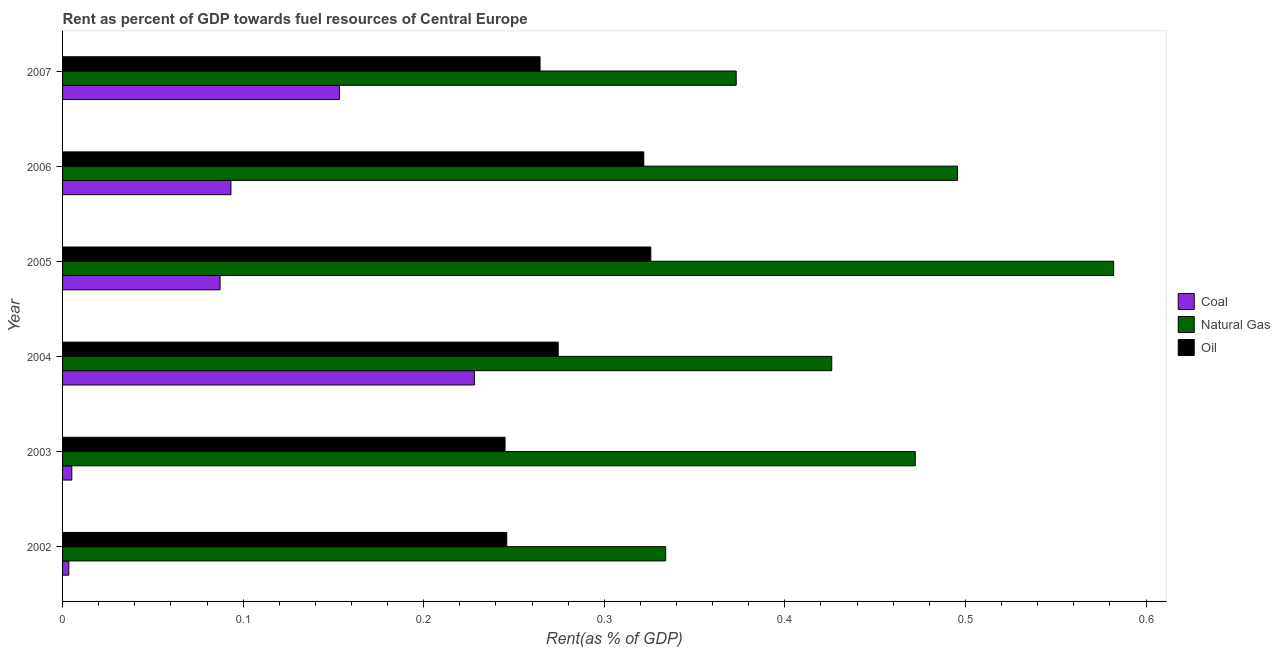How many different coloured bars are there?
Make the answer very short. 3. How many groups of bars are there?
Your answer should be compact. 6. How many bars are there on the 5th tick from the top?
Give a very brief answer. 3. How many bars are there on the 4th tick from the bottom?
Your response must be concise. 3. What is the rent towards natural gas in 2006?
Your answer should be compact. 0.5. Across all years, what is the maximum rent towards natural gas?
Your response must be concise. 0.58. Across all years, what is the minimum rent towards natural gas?
Keep it short and to the point. 0.33. In which year was the rent towards coal maximum?
Your answer should be very brief. 2004. What is the total rent towards natural gas in the graph?
Provide a short and direct response. 2.68. What is the difference between the rent towards coal in 2003 and that in 2007?
Provide a succinct answer. -0.15. What is the difference between the rent towards natural gas in 2006 and the rent towards coal in 2005?
Your answer should be very brief. 0.41. What is the average rent towards natural gas per year?
Keep it short and to the point. 0.45. In the year 2007, what is the difference between the rent towards natural gas and rent towards oil?
Offer a terse response. 0.11. In how many years, is the rent towards oil greater than 0.4 %?
Your answer should be very brief. 0. What is the ratio of the rent towards oil in 2002 to that in 2005?
Your response must be concise. 0.76. Is the rent towards coal in 2002 less than that in 2003?
Make the answer very short. Yes. Is the difference between the rent towards oil in 2006 and 2007 greater than the difference between the rent towards coal in 2006 and 2007?
Your answer should be very brief. Yes. What is the difference between the highest and the second highest rent towards coal?
Provide a succinct answer. 0.07. What is the difference between the highest and the lowest rent towards oil?
Your answer should be compact. 0.08. In how many years, is the rent towards coal greater than the average rent towards coal taken over all years?
Provide a short and direct response. 2. What does the 2nd bar from the top in 2006 represents?
Provide a short and direct response. Natural Gas. What does the 1st bar from the bottom in 2002 represents?
Keep it short and to the point. Coal. Is it the case that in every year, the sum of the rent towards coal and rent towards natural gas is greater than the rent towards oil?
Provide a succinct answer. Yes. How many bars are there?
Your answer should be very brief. 18. Are all the bars in the graph horizontal?
Provide a succinct answer. Yes. How many years are there in the graph?
Ensure brevity in your answer.  6. Does the graph contain grids?
Offer a terse response. No. How are the legend labels stacked?
Provide a succinct answer. Vertical. What is the title of the graph?
Your response must be concise. Rent as percent of GDP towards fuel resources of Central Europe. Does "Agricultural Nitrous Oxide" appear as one of the legend labels in the graph?
Your answer should be compact. No. What is the label or title of the X-axis?
Provide a succinct answer. Rent(as % of GDP). What is the label or title of the Y-axis?
Ensure brevity in your answer.  Year. What is the Rent(as % of GDP) in Coal in 2002?
Provide a short and direct response. 0. What is the Rent(as % of GDP) of Natural Gas in 2002?
Keep it short and to the point. 0.33. What is the Rent(as % of GDP) of Oil in 2002?
Offer a very short reply. 0.25. What is the Rent(as % of GDP) in Coal in 2003?
Provide a succinct answer. 0.01. What is the Rent(as % of GDP) of Natural Gas in 2003?
Keep it short and to the point. 0.47. What is the Rent(as % of GDP) of Oil in 2003?
Give a very brief answer. 0.25. What is the Rent(as % of GDP) of Coal in 2004?
Your answer should be compact. 0.23. What is the Rent(as % of GDP) in Natural Gas in 2004?
Give a very brief answer. 0.43. What is the Rent(as % of GDP) of Oil in 2004?
Ensure brevity in your answer.  0.27. What is the Rent(as % of GDP) of Coal in 2005?
Your answer should be very brief. 0.09. What is the Rent(as % of GDP) of Natural Gas in 2005?
Make the answer very short. 0.58. What is the Rent(as % of GDP) of Oil in 2005?
Offer a terse response. 0.33. What is the Rent(as % of GDP) of Coal in 2006?
Your response must be concise. 0.09. What is the Rent(as % of GDP) in Natural Gas in 2006?
Offer a terse response. 0.5. What is the Rent(as % of GDP) in Oil in 2006?
Keep it short and to the point. 0.32. What is the Rent(as % of GDP) in Coal in 2007?
Your response must be concise. 0.15. What is the Rent(as % of GDP) in Natural Gas in 2007?
Keep it short and to the point. 0.37. What is the Rent(as % of GDP) of Oil in 2007?
Make the answer very short. 0.26. Across all years, what is the maximum Rent(as % of GDP) of Coal?
Offer a terse response. 0.23. Across all years, what is the maximum Rent(as % of GDP) of Natural Gas?
Your response must be concise. 0.58. Across all years, what is the maximum Rent(as % of GDP) of Oil?
Keep it short and to the point. 0.33. Across all years, what is the minimum Rent(as % of GDP) in Coal?
Keep it short and to the point. 0. Across all years, what is the minimum Rent(as % of GDP) in Natural Gas?
Ensure brevity in your answer.  0.33. Across all years, what is the minimum Rent(as % of GDP) in Oil?
Provide a succinct answer. 0.25. What is the total Rent(as % of GDP) in Coal in the graph?
Ensure brevity in your answer.  0.57. What is the total Rent(as % of GDP) of Natural Gas in the graph?
Provide a succinct answer. 2.68. What is the total Rent(as % of GDP) in Oil in the graph?
Provide a succinct answer. 1.68. What is the difference between the Rent(as % of GDP) of Coal in 2002 and that in 2003?
Provide a short and direct response. -0. What is the difference between the Rent(as % of GDP) in Natural Gas in 2002 and that in 2003?
Provide a succinct answer. -0.14. What is the difference between the Rent(as % of GDP) of Oil in 2002 and that in 2003?
Provide a short and direct response. 0. What is the difference between the Rent(as % of GDP) in Coal in 2002 and that in 2004?
Provide a short and direct response. -0.22. What is the difference between the Rent(as % of GDP) in Natural Gas in 2002 and that in 2004?
Give a very brief answer. -0.09. What is the difference between the Rent(as % of GDP) of Oil in 2002 and that in 2004?
Keep it short and to the point. -0.03. What is the difference between the Rent(as % of GDP) in Coal in 2002 and that in 2005?
Your answer should be very brief. -0.08. What is the difference between the Rent(as % of GDP) of Natural Gas in 2002 and that in 2005?
Make the answer very short. -0.25. What is the difference between the Rent(as % of GDP) in Oil in 2002 and that in 2005?
Make the answer very short. -0.08. What is the difference between the Rent(as % of GDP) of Coal in 2002 and that in 2006?
Make the answer very short. -0.09. What is the difference between the Rent(as % of GDP) of Natural Gas in 2002 and that in 2006?
Give a very brief answer. -0.16. What is the difference between the Rent(as % of GDP) in Oil in 2002 and that in 2006?
Offer a terse response. -0.08. What is the difference between the Rent(as % of GDP) of Coal in 2002 and that in 2007?
Provide a succinct answer. -0.15. What is the difference between the Rent(as % of GDP) in Natural Gas in 2002 and that in 2007?
Ensure brevity in your answer.  -0.04. What is the difference between the Rent(as % of GDP) in Oil in 2002 and that in 2007?
Make the answer very short. -0.02. What is the difference between the Rent(as % of GDP) of Coal in 2003 and that in 2004?
Your response must be concise. -0.22. What is the difference between the Rent(as % of GDP) in Natural Gas in 2003 and that in 2004?
Ensure brevity in your answer.  0.05. What is the difference between the Rent(as % of GDP) in Oil in 2003 and that in 2004?
Provide a short and direct response. -0.03. What is the difference between the Rent(as % of GDP) in Coal in 2003 and that in 2005?
Your answer should be very brief. -0.08. What is the difference between the Rent(as % of GDP) of Natural Gas in 2003 and that in 2005?
Offer a terse response. -0.11. What is the difference between the Rent(as % of GDP) in Oil in 2003 and that in 2005?
Your answer should be compact. -0.08. What is the difference between the Rent(as % of GDP) in Coal in 2003 and that in 2006?
Make the answer very short. -0.09. What is the difference between the Rent(as % of GDP) in Natural Gas in 2003 and that in 2006?
Offer a very short reply. -0.02. What is the difference between the Rent(as % of GDP) of Oil in 2003 and that in 2006?
Your answer should be very brief. -0.08. What is the difference between the Rent(as % of GDP) of Coal in 2003 and that in 2007?
Offer a terse response. -0.15. What is the difference between the Rent(as % of GDP) of Natural Gas in 2003 and that in 2007?
Offer a terse response. 0.1. What is the difference between the Rent(as % of GDP) of Oil in 2003 and that in 2007?
Provide a short and direct response. -0.02. What is the difference between the Rent(as % of GDP) in Coal in 2004 and that in 2005?
Provide a short and direct response. 0.14. What is the difference between the Rent(as % of GDP) of Natural Gas in 2004 and that in 2005?
Provide a succinct answer. -0.16. What is the difference between the Rent(as % of GDP) of Oil in 2004 and that in 2005?
Make the answer very short. -0.05. What is the difference between the Rent(as % of GDP) of Coal in 2004 and that in 2006?
Offer a terse response. 0.13. What is the difference between the Rent(as % of GDP) of Natural Gas in 2004 and that in 2006?
Your answer should be very brief. -0.07. What is the difference between the Rent(as % of GDP) of Oil in 2004 and that in 2006?
Make the answer very short. -0.05. What is the difference between the Rent(as % of GDP) of Coal in 2004 and that in 2007?
Make the answer very short. 0.07. What is the difference between the Rent(as % of GDP) of Natural Gas in 2004 and that in 2007?
Provide a succinct answer. 0.05. What is the difference between the Rent(as % of GDP) of Oil in 2004 and that in 2007?
Your response must be concise. 0.01. What is the difference between the Rent(as % of GDP) of Coal in 2005 and that in 2006?
Keep it short and to the point. -0.01. What is the difference between the Rent(as % of GDP) in Natural Gas in 2005 and that in 2006?
Offer a terse response. 0.09. What is the difference between the Rent(as % of GDP) in Oil in 2005 and that in 2006?
Your answer should be compact. 0. What is the difference between the Rent(as % of GDP) of Coal in 2005 and that in 2007?
Give a very brief answer. -0.07. What is the difference between the Rent(as % of GDP) in Natural Gas in 2005 and that in 2007?
Your answer should be very brief. 0.21. What is the difference between the Rent(as % of GDP) in Oil in 2005 and that in 2007?
Provide a short and direct response. 0.06. What is the difference between the Rent(as % of GDP) in Coal in 2006 and that in 2007?
Provide a succinct answer. -0.06. What is the difference between the Rent(as % of GDP) of Natural Gas in 2006 and that in 2007?
Provide a succinct answer. 0.12. What is the difference between the Rent(as % of GDP) of Oil in 2006 and that in 2007?
Provide a short and direct response. 0.06. What is the difference between the Rent(as % of GDP) in Coal in 2002 and the Rent(as % of GDP) in Natural Gas in 2003?
Provide a succinct answer. -0.47. What is the difference between the Rent(as % of GDP) in Coal in 2002 and the Rent(as % of GDP) in Oil in 2003?
Provide a short and direct response. -0.24. What is the difference between the Rent(as % of GDP) of Natural Gas in 2002 and the Rent(as % of GDP) of Oil in 2003?
Offer a terse response. 0.09. What is the difference between the Rent(as % of GDP) in Coal in 2002 and the Rent(as % of GDP) in Natural Gas in 2004?
Your answer should be very brief. -0.42. What is the difference between the Rent(as % of GDP) of Coal in 2002 and the Rent(as % of GDP) of Oil in 2004?
Ensure brevity in your answer.  -0.27. What is the difference between the Rent(as % of GDP) in Natural Gas in 2002 and the Rent(as % of GDP) in Oil in 2004?
Your response must be concise. 0.06. What is the difference between the Rent(as % of GDP) in Coal in 2002 and the Rent(as % of GDP) in Natural Gas in 2005?
Give a very brief answer. -0.58. What is the difference between the Rent(as % of GDP) of Coal in 2002 and the Rent(as % of GDP) of Oil in 2005?
Offer a very short reply. -0.32. What is the difference between the Rent(as % of GDP) in Natural Gas in 2002 and the Rent(as % of GDP) in Oil in 2005?
Offer a very short reply. 0.01. What is the difference between the Rent(as % of GDP) in Coal in 2002 and the Rent(as % of GDP) in Natural Gas in 2006?
Offer a terse response. -0.49. What is the difference between the Rent(as % of GDP) of Coal in 2002 and the Rent(as % of GDP) of Oil in 2006?
Your response must be concise. -0.32. What is the difference between the Rent(as % of GDP) in Natural Gas in 2002 and the Rent(as % of GDP) in Oil in 2006?
Ensure brevity in your answer.  0.01. What is the difference between the Rent(as % of GDP) of Coal in 2002 and the Rent(as % of GDP) of Natural Gas in 2007?
Keep it short and to the point. -0.37. What is the difference between the Rent(as % of GDP) in Coal in 2002 and the Rent(as % of GDP) in Oil in 2007?
Give a very brief answer. -0.26. What is the difference between the Rent(as % of GDP) of Natural Gas in 2002 and the Rent(as % of GDP) of Oil in 2007?
Provide a succinct answer. 0.07. What is the difference between the Rent(as % of GDP) of Coal in 2003 and the Rent(as % of GDP) of Natural Gas in 2004?
Ensure brevity in your answer.  -0.42. What is the difference between the Rent(as % of GDP) in Coal in 2003 and the Rent(as % of GDP) in Oil in 2004?
Provide a succinct answer. -0.27. What is the difference between the Rent(as % of GDP) of Natural Gas in 2003 and the Rent(as % of GDP) of Oil in 2004?
Provide a succinct answer. 0.2. What is the difference between the Rent(as % of GDP) in Coal in 2003 and the Rent(as % of GDP) in Natural Gas in 2005?
Provide a succinct answer. -0.58. What is the difference between the Rent(as % of GDP) in Coal in 2003 and the Rent(as % of GDP) in Oil in 2005?
Keep it short and to the point. -0.32. What is the difference between the Rent(as % of GDP) of Natural Gas in 2003 and the Rent(as % of GDP) of Oil in 2005?
Your answer should be compact. 0.15. What is the difference between the Rent(as % of GDP) of Coal in 2003 and the Rent(as % of GDP) of Natural Gas in 2006?
Ensure brevity in your answer.  -0.49. What is the difference between the Rent(as % of GDP) of Coal in 2003 and the Rent(as % of GDP) of Oil in 2006?
Offer a very short reply. -0.32. What is the difference between the Rent(as % of GDP) in Natural Gas in 2003 and the Rent(as % of GDP) in Oil in 2006?
Your answer should be very brief. 0.15. What is the difference between the Rent(as % of GDP) in Coal in 2003 and the Rent(as % of GDP) in Natural Gas in 2007?
Provide a succinct answer. -0.37. What is the difference between the Rent(as % of GDP) in Coal in 2003 and the Rent(as % of GDP) in Oil in 2007?
Your answer should be very brief. -0.26. What is the difference between the Rent(as % of GDP) of Natural Gas in 2003 and the Rent(as % of GDP) of Oil in 2007?
Make the answer very short. 0.21. What is the difference between the Rent(as % of GDP) in Coal in 2004 and the Rent(as % of GDP) in Natural Gas in 2005?
Make the answer very short. -0.35. What is the difference between the Rent(as % of GDP) in Coal in 2004 and the Rent(as % of GDP) in Oil in 2005?
Keep it short and to the point. -0.1. What is the difference between the Rent(as % of GDP) of Natural Gas in 2004 and the Rent(as % of GDP) of Oil in 2005?
Your response must be concise. 0.1. What is the difference between the Rent(as % of GDP) in Coal in 2004 and the Rent(as % of GDP) in Natural Gas in 2006?
Ensure brevity in your answer.  -0.27. What is the difference between the Rent(as % of GDP) in Coal in 2004 and the Rent(as % of GDP) in Oil in 2006?
Give a very brief answer. -0.09. What is the difference between the Rent(as % of GDP) in Natural Gas in 2004 and the Rent(as % of GDP) in Oil in 2006?
Provide a succinct answer. 0.1. What is the difference between the Rent(as % of GDP) in Coal in 2004 and the Rent(as % of GDP) in Natural Gas in 2007?
Make the answer very short. -0.14. What is the difference between the Rent(as % of GDP) of Coal in 2004 and the Rent(as % of GDP) of Oil in 2007?
Provide a succinct answer. -0.04. What is the difference between the Rent(as % of GDP) in Natural Gas in 2004 and the Rent(as % of GDP) in Oil in 2007?
Offer a terse response. 0.16. What is the difference between the Rent(as % of GDP) of Coal in 2005 and the Rent(as % of GDP) of Natural Gas in 2006?
Make the answer very short. -0.41. What is the difference between the Rent(as % of GDP) of Coal in 2005 and the Rent(as % of GDP) of Oil in 2006?
Make the answer very short. -0.23. What is the difference between the Rent(as % of GDP) in Natural Gas in 2005 and the Rent(as % of GDP) in Oil in 2006?
Your response must be concise. 0.26. What is the difference between the Rent(as % of GDP) of Coal in 2005 and the Rent(as % of GDP) of Natural Gas in 2007?
Make the answer very short. -0.29. What is the difference between the Rent(as % of GDP) in Coal in 2005 and the Rent(as % of GDP) in Oil in 2007?
Keep it short and to the point. -0.18. What is the difference between the Rent(as % of GDP) of Natural Gas in 2005 and the Rent(as % of GDP) of Oil in 2007?
Make the answer very short. 0.32. What is the difference between the Rent(as % of GDP) in Coal in 2006 and the Rent(as % of GDP) in Natural Gas in 2007?
Your answer should be compact. -0.28. What is the difference between the Rent(as % of GDP) in Coal in 2006 and the Rent(as % of GDP) in Oil in 2007?
Give a very brief answer. -0.17. What is the difference between the Rent(as % of GDP) of Natural Gas in 2006 and the Rent(as % of GDP) of Oil in 2007?
Offer a terse response. 0.23. What is the average Rent(as % of GDP) of Coal per year?
Your answer should be very brief. 0.1. What is the average Rent(as % of GDP) in Natural Gas per year?
Your response must be concise. 0.45. What is the average Rent(as % of GDP) of Oil per year?
Make the answer very short. 0.28. In the year 2002, what is the difference between the Rent(as % of GDP) of Coal and Rent(as % of GDP) of Natural Gas?
Provide a succinct answer. -0.33. In the year 2002, what is the difference between the Rent(as % of GDP) of Coal and Rent(as % of GDP) of Oil?
Your answer should be very brief. -0.24. In the year 2002, what is the difference between the Rent(as % of GDP) of Natural Gas and Rent(as % of GDP) of Oil?
Your answer should be compact. 0.09. In the year 2003, what is the difference between the Rent(as % of GDP) of Coal and Rent(as % of GDP) of Natural Gas?
Give a very brief answer. -0.47. In the year 2003, what is the difference between the Rent(as % of GDP) in Coal and Rent(as % of GDP) in Oil?
Keep it short and to the point. -0.24. In the year 2003, what is the difference between the Rent(as % of GDP) of Natural Gas and Rent(as % of GDP) of Oil?
Give a very brief answer. 0.23. In the year 2004, what is the difference between the Rent(as % of GDP) of Coal and Rent(as % of GDP) of Natural Gas?
Offer a very short reply. -0.2. In the year 2004, what is the difference between the Rent(as % of GDP) in Coal and Rent(as % of GDP) in Oil?
Ensure brevity in your answer.  -0.05. In the year 2004, what is the difference between the Rent(as % of GDP) in Natural Gas and Rent(as % of GDP) in Oil?
Provide a short and direct response. 0.15. In the year 2005, what is the difference between the Rent(as % of GDP) of Coal and Rent(as % of GDP) of Natural Gas?
Your answer should be compact. -0.49. In the year 2005, what is the difference between the Rent(as % of GDP) of Coal and Rent(as % of GDP) of Oil?
Offer a very short reply. -0.24. In the year 2005, what is the difference between the Rent(as % of GDP) of Natural Gas and Rent(as % of GDP) of Oil?
Your answer should be compact. 0.26. In the year 2006, what is the difference between the Rent(as % of GDP) of Coal and Rent(as % of GDP) of Natural Gas?
Offer a terse response. -0.4. In the year 2006, what is the difference between the Rent(as % of GDP) in Coal and Rent(as % of GDP) in Oil?
Offer a very short reply. -0.23. In the year 2006, what is the difference between the Rent(as % of GDP) in Natural Gas and Rent(as % of GDP) in Oil?
Ensure brevity in your answer.  0.17. In the year 2007, what is the difference between the Rent(as % of GDP) in Coal and Rent(as % of GDP) in Natural Gas?
Give a very brief answer. -0.22. In the year 2007, what is the difference between the Rent(as % of GDP) of Coal and Rent(as % of GDP) of Oil?
Offer a very short reply. -0.11. In the year 2007, what is the difference between the Rent(as % of GDP) of Natural Gas and Rent(as % of GDP) of Oil?
Ensure brevity in your answer.  0.11. What is the ratio of the Rent(as % of GDP) of Coal in 2002 to that in 2003?
Your answer should be compact. 0.67. What is the ratio of the Rent(as % of GDP) in Natural Gas in 2002 to that in 2003?
Make the answer very short. 0.71. What is the ratio of the Rent(as % of GDP) in Oil in 2002 to that in 2003?
Your answer should be very brief. 1. What is the ratio of the Rent(as % of GDP) of Coal in 2002 to that in 2004?
Your response must be concise. 0.02. What is the ratio of the Rent(as % of GDP) in Natural Gas in 2002 to that in 2004?
Your answer should be very brief. 0.78. What is the ratio of the Rent(as % of GDP) in Oil in 2002 to that in 2004?
Your answer should be very brief. 0.9. What is the ratio of the Rent(as % of GDP) of Coal in 2002 to that in 2005?
Provide a succinct answer. 0.04. What is the ratio of the Rent(as % of GDP) of Natural Gas in 2002 to that in 2005?
Offer a terse response. 0.57. What is the ratio of the Rent(as % of GDP) of Oil in 2002 to that in 2005?
Provide a succinct answer. 0.76. What is the ratio of the Rent(as % of GDP) of Coal in 2002 to that in 2006?
Provide a short and direct response. 0.04. What is the ratio of the Rent(as % of GDP) in Natural Gas in 2002 to that in 2006?
Your answer should be compact. 0.67. What is the ratio of the Rent(as % of GDP) in Oil in 2002 to that in 2006?
Provide a short and direct response. 0.76. What is the ratio of the Rent(as % of GDP) in Coal in 2002 to that in 2007?
Keep it short and to the point. 0.02. What is the ratio of the Rent(as % of GDP) of Natural Gas in 2002 to that in 2007?
Ensure brevity in your answer.  0.9. What is the ratio of the Rent(as % of GDP) of Oil in 2002 to that in 2007?
Make the answer very short. 0.93. What is the ratio of the Rent(as % of GDP) of Coal in 2003 to that in 2004?
Provide a short and direct response. 0.02. What is the ratio of the Rent(as % of GDP) in Natural Gas in 2003 to that in 2004?
Offer a terse response. 1.11. What is the ratio of the Rent(as % of GDP) in Oil in 2003 to that in 2004?
Provide a succinct answer. 0.89. What is the ratio of the Rent(as % of GDP) of Coal in 2003 to that in 2005?
Give a very brief answer. 0.06. What is the ratio of the Rent(as % of GDP) of Natural Gas in 2003 to that in 2005?
Give a very brief answer. 0.81. What is the ratio of the Rent(as % of GDP) of Oil in 2003 to that in 2005?
Your response must be concise. 0.75. What is the ratio of the Rent(as % of GDP) in Coal in 2003 to that in 2006?
Your answer should be compact. 0.05. What is the ratio of the Rent(as % of GDP) of Natural Gas in 2003 to that in 2006?
Provide a short and direct response. 0.95. What is the ratio of the Rent(as % of GDP) of Oil in 2003 to that in 2006?
Make the answer very short. 0.76. What is the ratio of the Rent(as % of GDP) in Coal in 2003 to that in 2007?
Keep it short and to the point. 0.03. What is the ratio of the Rent(as % of GDP) in Natural Gas in 2003 to that in 2007?
Provide a succinct answer. 1.27. What is the ratio of the Rent(as % of GDP) of Oil in 2003 to that in 2007?
Provide a short and direct response. 0.93. What is the ratio of the Rent(as % of GDP) in Coal in 2004 to that in 2005?
Your answer should be compact. 2.61. What is the ratio of the Rent(as % of GDP) of Natural Gas in 2004 to that in 2005?
Ensure brevity in your answer.  0.73. What is the ratio of the Rent(as % of GDP) of Oil in 2004 to that in 2005?
Your answer should be compact. 0.84. What is the ratio of the Rent(as % of GDP) in Coal in 2004 to that in 2006?
Your answer should be very brief. 2.45. What is the ratio of the Rent(as % of GDP) in Natural Gas in 2004 to that in 2006?
Your answer should be compact. 0.86. What is the ratio of the Rent(as % of GDP) in Oil in 2004 to that in 2006?
Offer a very short reply. 0.85. What is the ratio of the Rent(as % of GDP) of Coal in 2004 to that in 2007?
Your answer should be very brief. 1.49. What is the ratio of the Rent(as % of GDP) of Natural Gas in 2004 to that in 2007?
Keep it short and to the point. 1.14. What is the ratio of the Rent(as % of GDP) of Oil in 2004 to that in 2007?
Provide a short and direct response. 1.04. What is the ratio of the Rent(as % of GDP) in Coal in 2005 to that in 2006?
Keep it short and to the point. 0.94. What is the ratio of the Rent(as % of GDP) in Natural Gas in 2005 to that in 2006?
Make the answer very short. 1.17. What is the ratio of the Rent(as % of GDP) of Oil in 2005 to that in 2006?
Offer a terse response. 1.01. What is the ratio of the Rent(as % of GDP) of Coal in 2005 to that in 2007?
Keep it short and to the point. 0.57. What is the ratio of the Rent(as % of GDP) in Natural Gas in 2005 to that in 2007?
Provide a short and direct response. 1.56. What is the ratio of the Rent(as % of GDP) of Oil in 2005 to that in 2007?
Your answer should be compact. 1.23. What is the ratio of the Rent(as % of GDP) in Coal in 2006 to that in 2007?
Make the answer very short. 0.61. What is the ratio of the Rent(as % of GDP) of Natural Gas in 2006 to that in 2007?
Offer a very short reply. 1.33. What is the ratio of the Rent(as % of GDP) in Oil in 2006 to that in 2007?
Offer a very short reply. 1.22. What is the difference between the highest and the second highest Rent(as % of GDP) of Coal?
Your answer should be compact. 0.07. What is the difference between the highest and the second highest Rent(as % of GDP) of Natural Gas?
Give a very brief answer. 0.09. What is the difference between the highest and the second highest Rent(as % of GDP) in Oil?
Your response must be concise. 0. What is the difference between the highest and the lowest Rent(as % of GDP) of Coal?
Give a very brief answer. 0.22. What is the difference between the highest and the lowest Rent(as % of GDP) of Natural Gas?
Provide a succinct answer. 0.25. What is the difference between the highest and the lowest Rent(as % of GDP) of Oil?
Offer a very short reply. 0.08. 